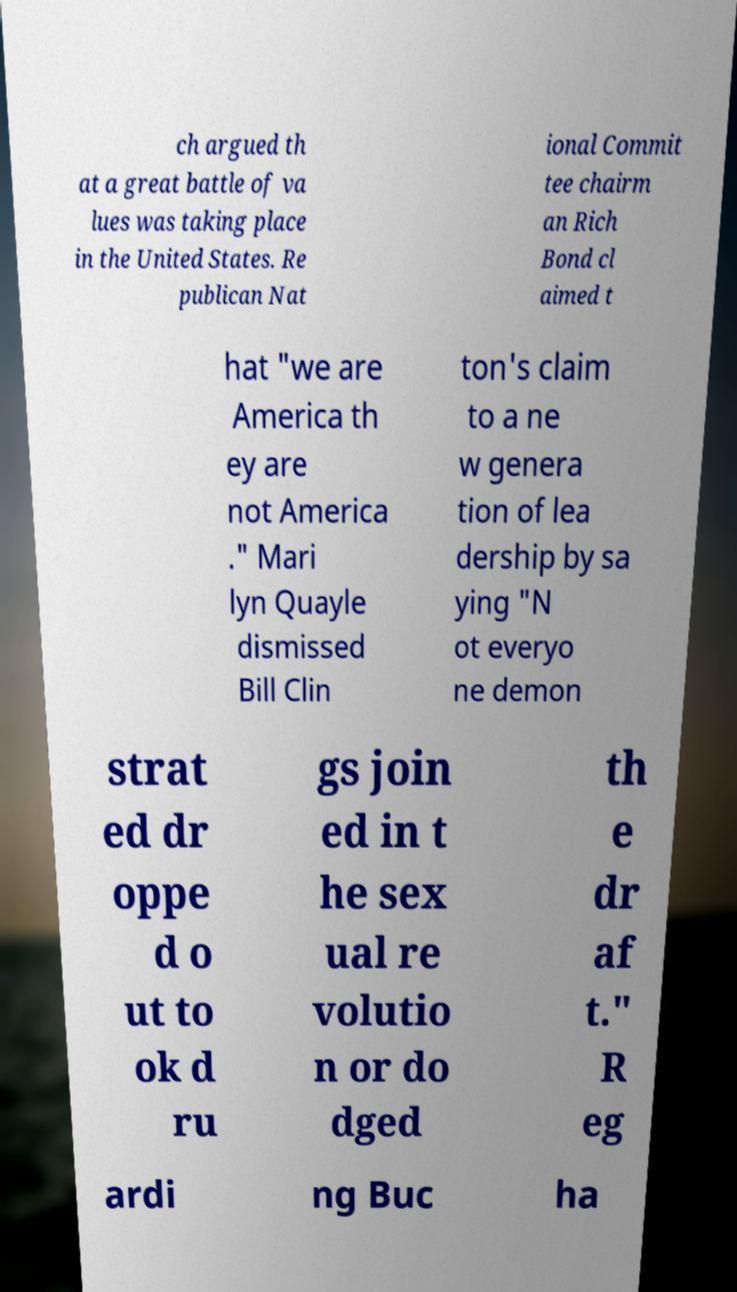Please read and relay the text visible in this image. What does it say? ch argued th at a great battle of va lues was taking place in the United States. Re publican Nat ional Commit tee chairm an Rich Bond cl aimed t hat "we are America th ey are not America ." Mari lyn Quayle dismissed Bill Clin ton's claim to a ne w genera tion of lea dership by sa ying "N ot everyo ne demon strat ed dr oppe d o ut to ok d ru gs join ed in t he sex ual re volutio n or do dged th e dr af t." R eg ardi ng Buc ha 